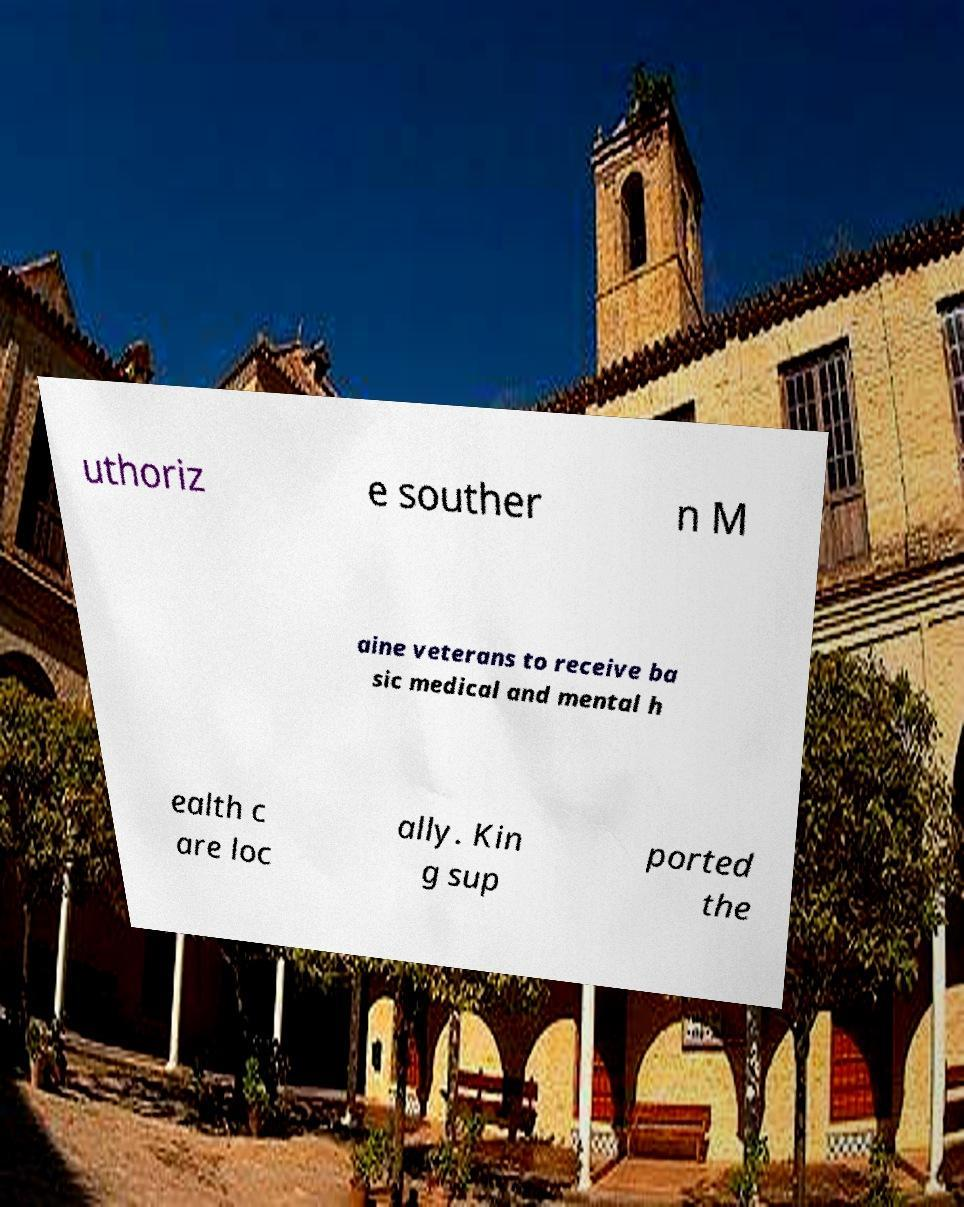Can you read and provide the text displayed in the image?This photo seems to have some interesting text. Can you extract and type it out for me? uthoriz e souther n M aine veterans to receive ba sic medical and mental h ealth c are loc ally. Kin g sup ported the 